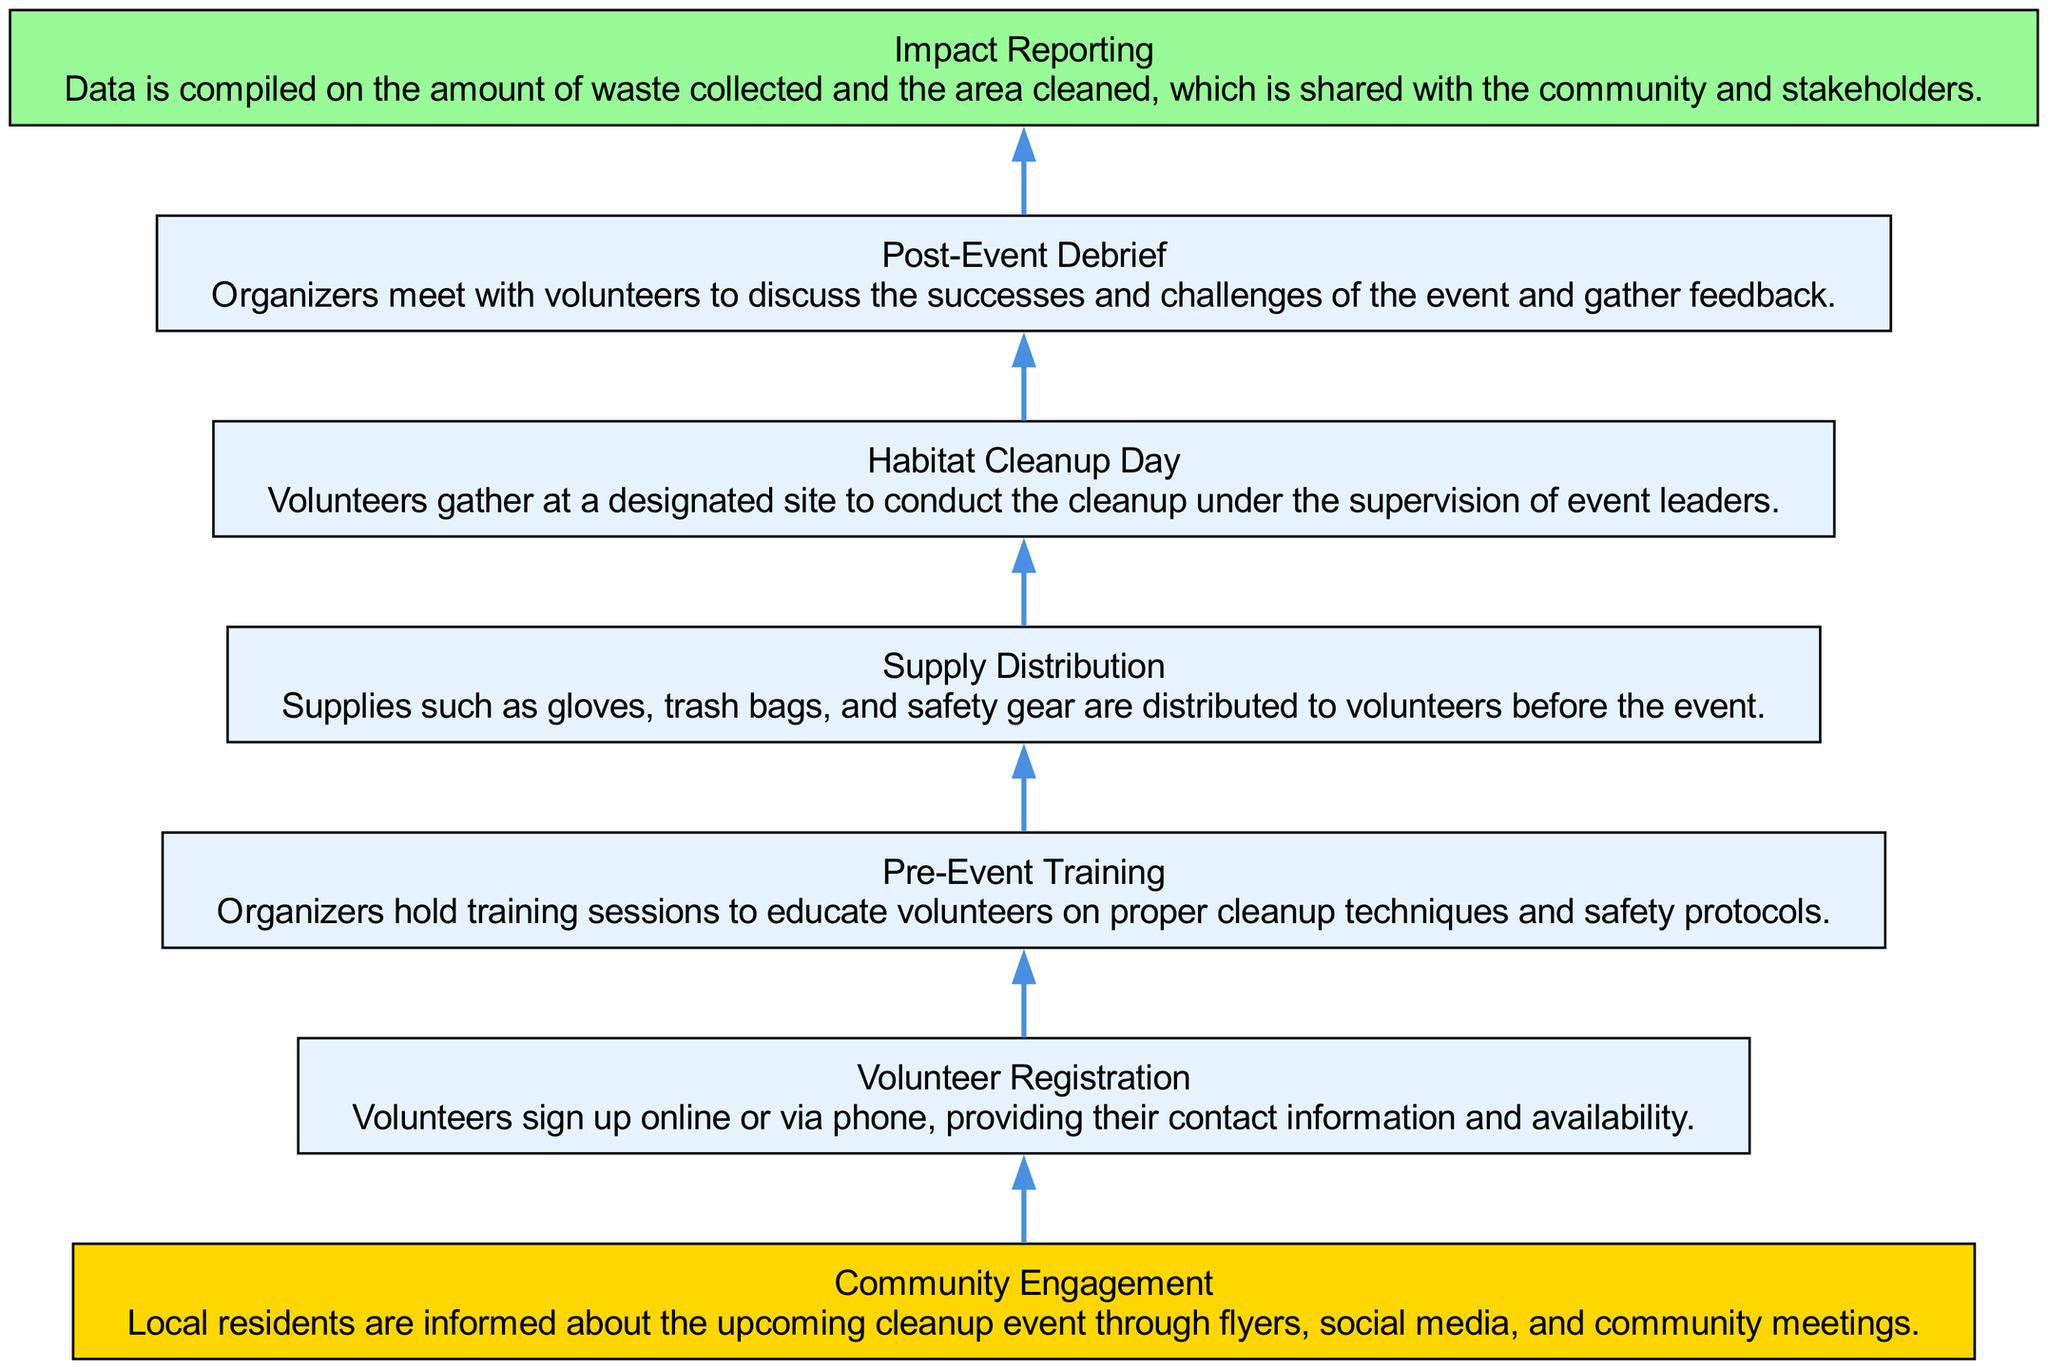What is the first step in the volunteer engagement flow? The diagram indicates that "Community Engagement" is the first step, as it is positioned at the bottom and has no incoming arrows.
Answer: Community Engagement How many nodes are in the diagram? Counting each unique step in the process, there are seven nodes representing the various stages of volunteer engagement from "Community Engagement" to "Impact Reporting."
Answer: 7 What is the final step in the process? The last step in the diagram is "Impact Reporting." It is the topmost node and has no outgoing edges.
Answer: Impact Reporting Which step involves providing volunteers with cleanup supplies? The "Supply Distribution" step is specifically related to the distribution of gloves, trash bags, and safety gear to volunteers before the cleanup event.
Answer: Supply Distribution What is the relationship between "Volunteer Registration" and "Pre-Event Training"? "Volunteer Registration" leads to "Pre-Event Training," as indicated by the directed edge that connects the two nodes, showing that registration must happen first.
Answer: Leads to What is the primary goal of the "Post-Event Debrief"? The goal of the "Post-Event Debrief" is to discuss the successes and challenges of the event with the volunteers, gathering feedback based on their experiences.
Answer: Gather feedback How many edges connect the nodes in the diagram? The diagram shows six directed edges, connecting each step from "Community Engagement" to "Impact Reporting."
Answer: 6 What signifies the end of the volunteer engagement flow? The "Impact Reporting" node is colored differently from the other nodes, indicating that it is the final step in the engagement flow.
Answer: Impact Reporting What step follows "Pre-Event Training"? According to the flow diagram, the step that follows "Pre-Event Training" is "Supply Distribution." This is shown through the directed edge.
Answer: Supply Distribution 